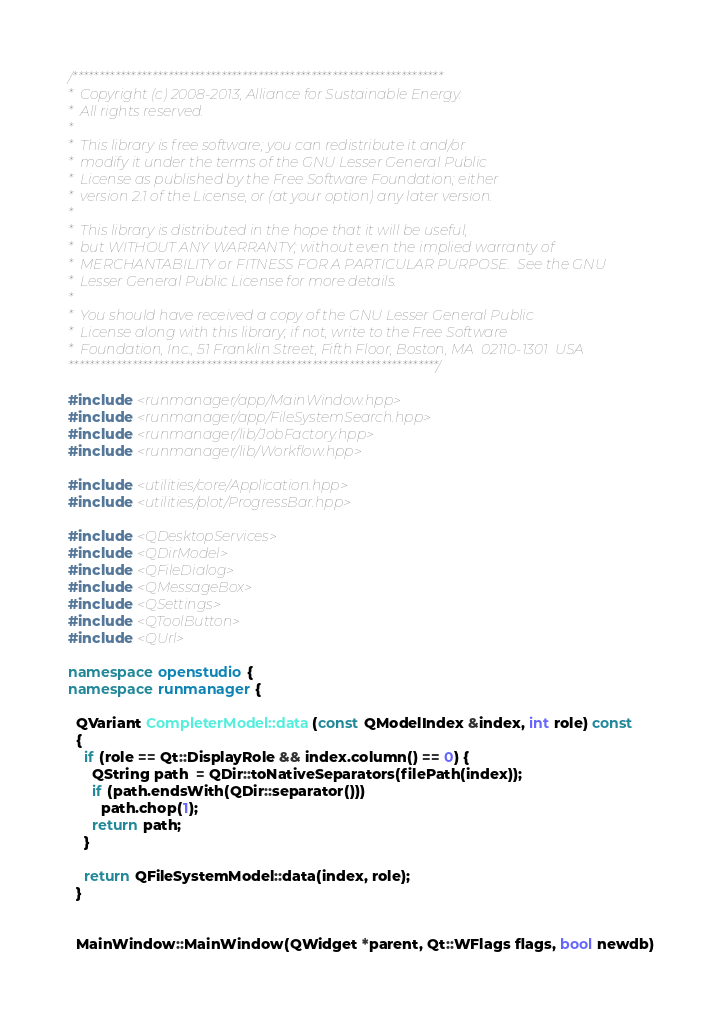Convert code to text. <code><loc_0><loc_0><loc_500><loc_500><_C++_>/**********************************************************************
*  Copyright (c) 2008-2013, Alliance for Sustainable Energy.  
*  All rights reserved.
*  
*  This library is free software; you can redistribute it and/or
*  modify it under the terms of the GNU Lesser General Public
*  License as published by the Free Software Foundation; either
*  version 2.1 of the License, or (at your option) any later version.
*  
*  This library is distributed in the hope that it will be useful,
*  but WITHOUT ANY WARRANTY; without even the implied warranty of
*  MERCHANTABILITY or FITNESS FOR A PARTICULAR PURPOSE.  See the GNU
*  Lesser General Public License for more details.
*  
*  You should have received a copy of the GNU Lesser General Public
*  License along with this library; if not, write to the Free Software
*  Foundation, Inc., 51 Franklin Street, Fifth Floor, Boston, MA  02110-1301  USA
**********************************************************************/

#include <runmanager/app/MainWindow.hpp>
#include <runmanager/app/FileSystemSearch.hpp>
#include <runmanager/lib/JobFactory.hpp>
#include <runmanager/lib/Workflow.hpp>

#include <utilities/core/Application.hpp>
#include <utilities/plot/ProgressBar.hpp>

#include <QDesktopServices>
#include <QDirModel>
#include <QFileDialog>
#include <QMessageBox>
#include <QSettings>
#include <QToolButton>
#include <QUrl>

namespace openstudio {
namespace runmanager {

  QVariant CompleterModel::data(const QModelIndex &index, int role) const
  {
    if (role == Qt::DisplayRole && index.column() == 0) {
      QString path  = QDir::toNativeSeparators(filePath(index));
      if (path.endsWith(QDir::separator()))
        path.chop(1);
      return path;
    }

    return QFileSystemModel::data(index, role);
  }


  MainWindow::MainWindow(QWidget *parent, Qt::WFlags flags, bool newdb)</code> 